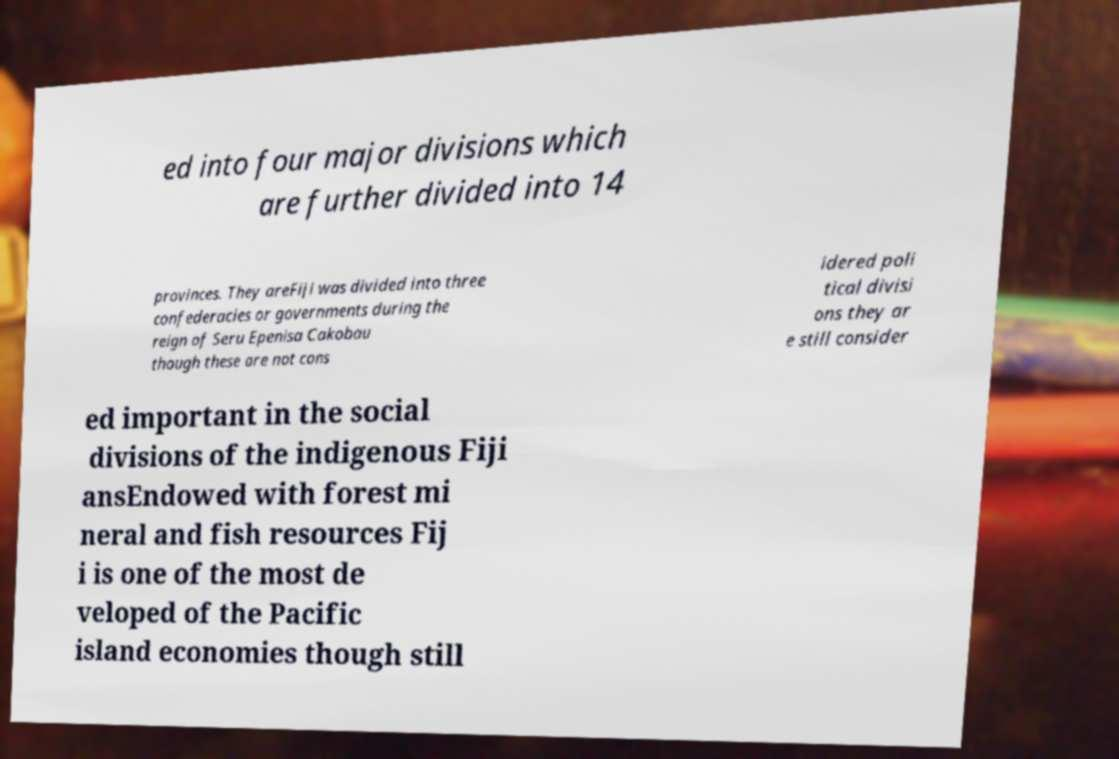Please read and relay the text visible in this image. What does it say? ed into four major divisions which are further divided into 14 provinces. They areFiji was divided into three confederacies or governments during the reign of Seru Epenisa Cakobau though these are not cons idered poli tical divisi ons they ar e still consider ed important in the social divisions of the indigenous Fiji ansEndowed with forest mi neral and fish resources Fij i is one of the most de veloped of the Pacific island economies though still 